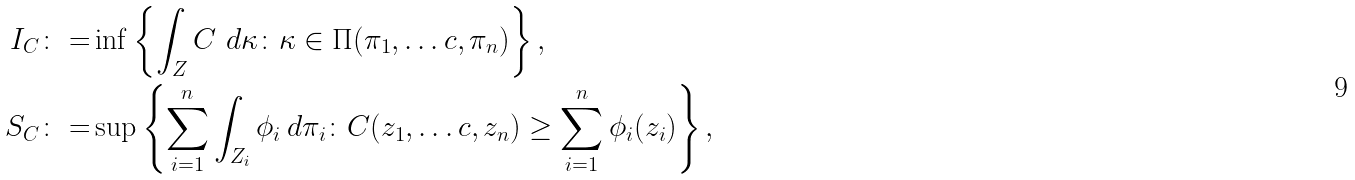Convert formula to latex. <formula><loc_0><loc_0><loc_500><loc_500>I _ { C } \colon = & \inf \left \{ \int _ { Z } C \ d \kappa \colon \kappa \in \Pi ( \pi _ { 1 } , \dots c , \pi _ { n } ) \right \} , \\ S _ { C } \colon = & \sup \left \{ \sum _ { i = 1 } ^ { n } \int _ { Z _ { i } } \phi _ { i } \, d \pi _ { i } \colon C ( z _ { 1 } , \dots c , z _ { n } ) \geq \sum _ { i = 1 } ^ { n } \phi _ { i } ( z _ { i } ) \right \} ,</formula> 